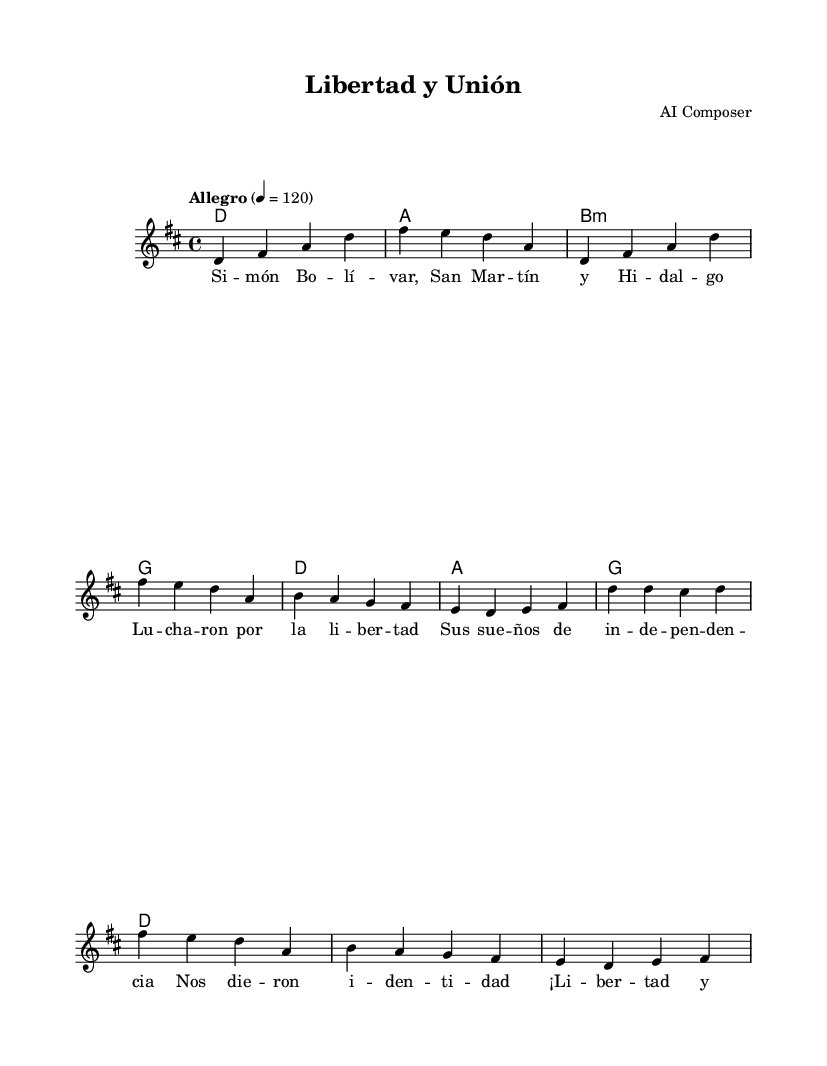What is the key signature of this music? The key signature is indicated by the sharp found in the key signature section. Here, there is a F# which means it is in D major, which contains two sharps: F# and C#.
Answer: D major What is the time signature of this piece? The time signature is shown at the beginning of the score. It is written as 4/4, meaning there are four beats per measure and the quarter note gets one beat.
Answer: 4/4 What is the tempo marking for this piece? The tempo is indicated by the text "Allegro" followed by a metronome marking of 120. Allegro suggests a fast pace, and the markings confirm a specific speed of beats.
Answer: Allegro, 120 What are the first two notes of the melody? The melody begins with the notes D and F#, which can be identified from the first measure of the melody section.
Answer: D, F# How many measures are in the chorus section? By examining the chorus lyrics and counting the measures beneath them in the score, there are a total of four measures in the chorus part.
Answer: 4 What do the lyrics of the chorus celebrate? The chorus lyrics contain the repetition of "¡Libertad y Unión!" which translates to "Liberty and Union!" This indicates a celebration of freedom and unity, particularly relevant to independence movements.
Answer: Liberty and Union What is the overall theme conveyed by the lyrics? The lyrics express concepts associated with liberation, identity, and the aspirations of independence for Latin American nations, featuring a strong revolutionary mindset.
Answer: Independence and identity 